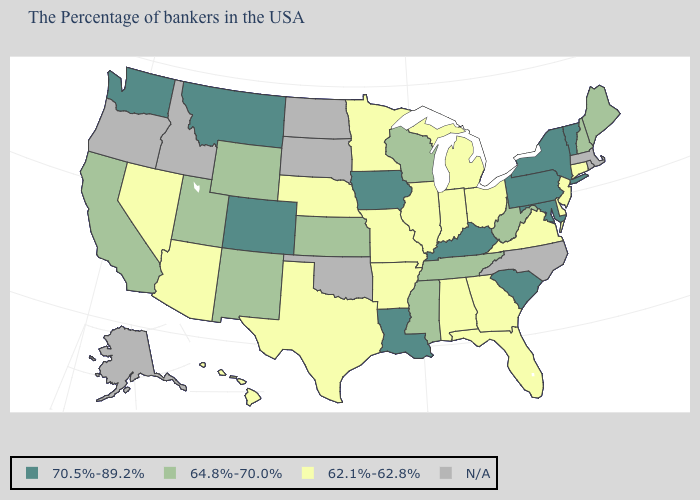What is the value of North Dakota?
Concise answer only. N/A. What is the value of Kentucky?
Give a very brief answer. 70.5%-89.2%. What is the value of Ohio?
Write a very short answer. 62.1%-62.8%. Is the legend a continuous bar?
Concise answer only. No. Name the states that have a value in the range 62.1%-62.8%?
Concise answer only. Connecticut, New Jersey, Delaware, Virginia, Ohio, Florida, Georgia, Michigan, Indiana, Alabama, Illinois, Missouri, Arkansas, Minnesota, Nebraska, Texas, Arizona, Nevada, Hawaii. What is the value of Illinois?
Give a very brief answer. 62.1%-62.8%. Which states have the highest value in the USA?
Concise answer only. Vermont, New York, Maryland, Pennsylvania, South Carolina, Kentucky, Louisiana, Iowa, Colorado, Montana, Washington. Name the states that have a value in the range N/A?
Short answer required. Massachusetts, Rhode Island, North Carolina, Oklahoma, South Dakota, North Dakota, Idaho, Oregon, Alaska. How many symbols are there in the legend?
Keep it brief. 4. Does the first symbol in the legend represent the smallest category?
Be succinct. No. Name the states that have a value in the range 62.1%-62.8%?
Be succinct. Connecticut, New Jersey, Delaware, Virginia, Ohio, Florida, Georgia, Michigan, Indiana, Alabama, Illinois, Missouri, Arkansas, Minnesota, Nebraska, Texas, Arizona, Nevada, Hawaii. Name the states that have a value in the range 64.8%-70.0%?
Keep it brief. Maine, New Hampshire, West Virginia, Tennessee, Wisconsin, Mississippi, Kansas, Wyoming, New Mexico, Utah, California. Which states have the lowest value in the Northeast?
Write a very short answer. Connecticut, New Jersey. Name the states that have a value in the range N/A?
Give a very brief answer. Massachusetts, Rhode Island, North Carolina, Oklahoma, South Dakota, North Dakota, Idaho, Oregon, Alaska. 